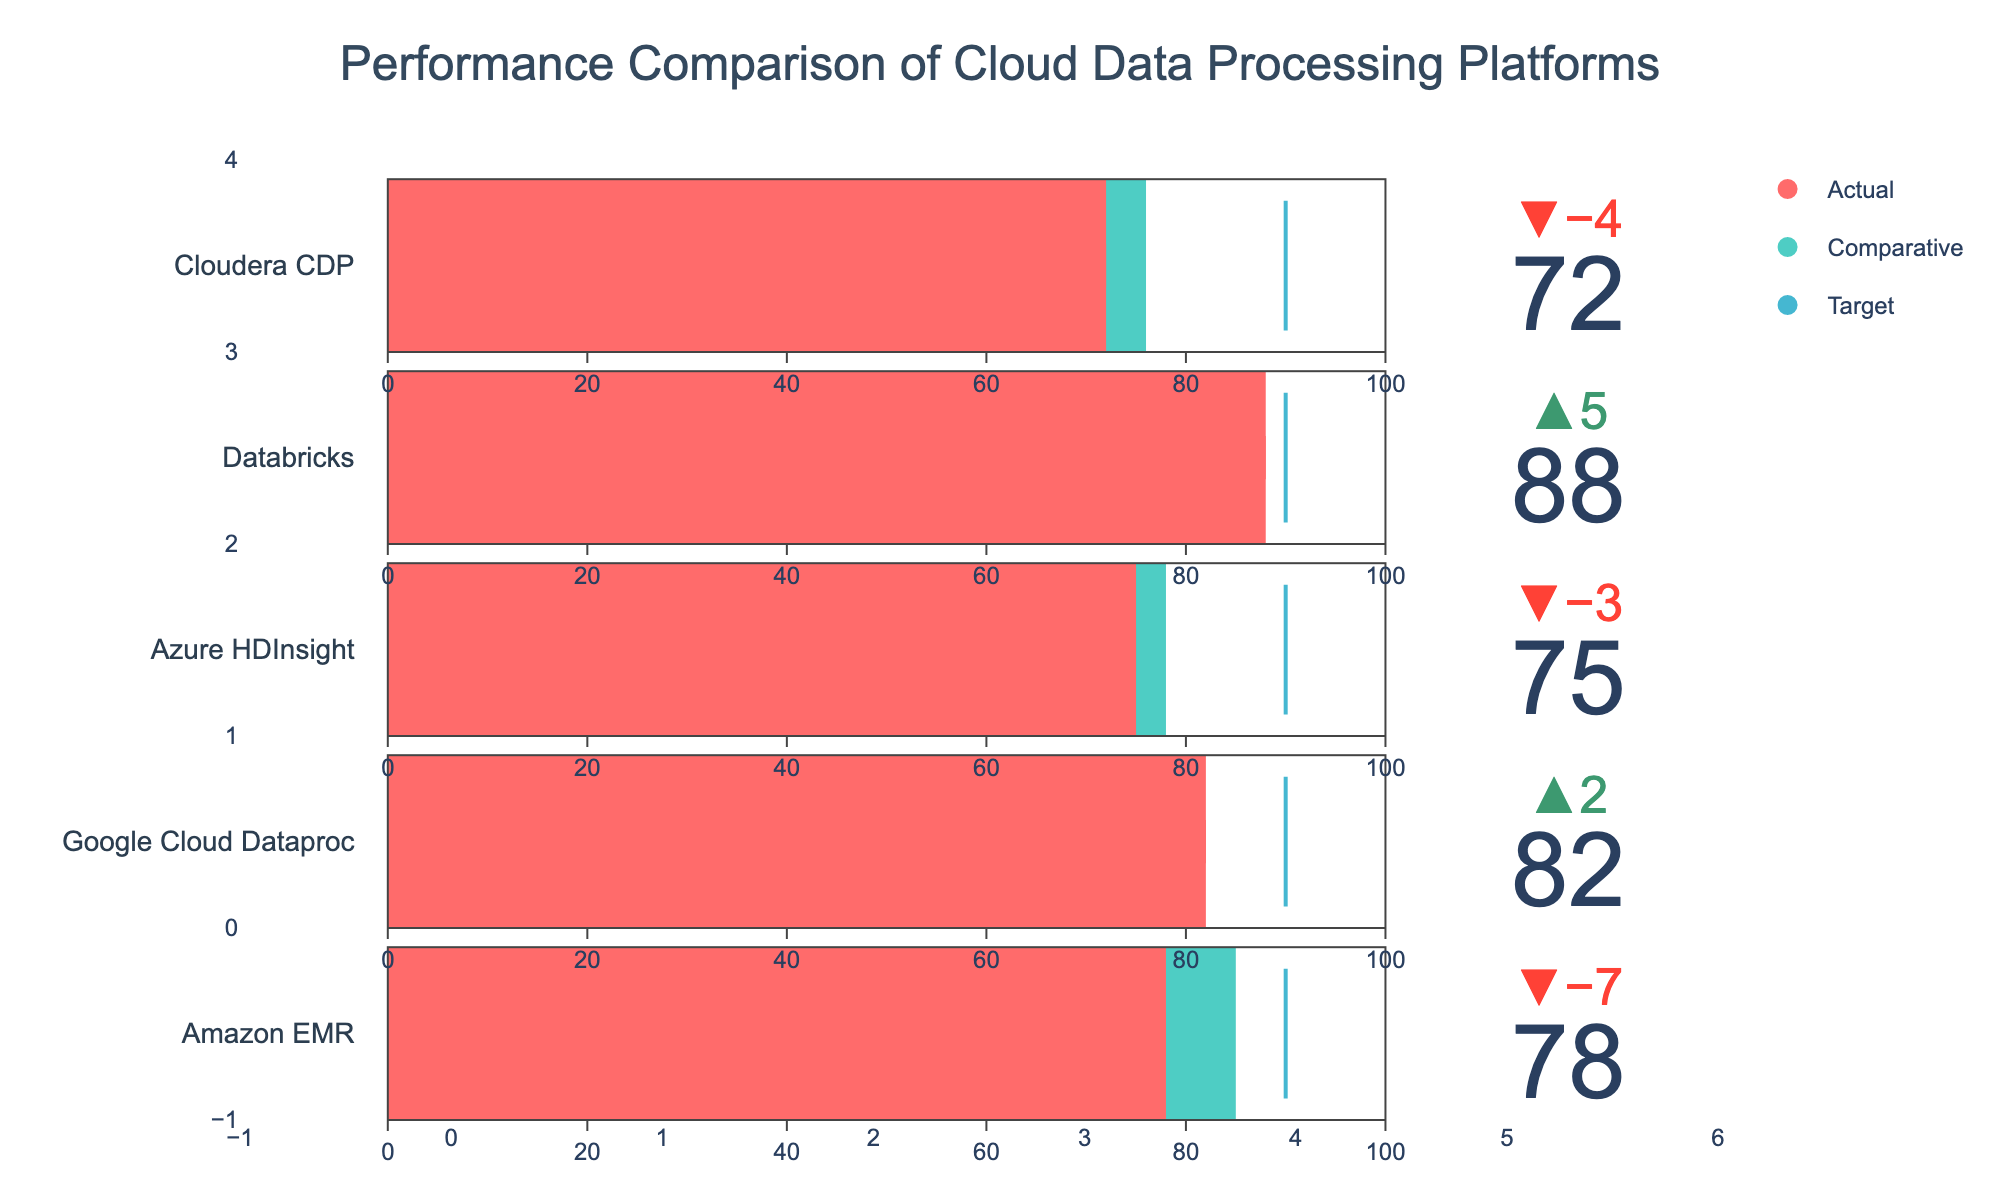What is the title of the plot? The title of the plot is located at the top and clearly states the focus of the visualization. The plot is titled "Performance Comparison of Cloud Data Processing Platforms".
Answer: Performance Comparison of Cloud Data Processing Platforms Which cloud data processing platform has the highest actual performance? To determine the highest actual performance, we need to compare the 'Actual' values of all platforms. Databricks has the highest actual performance of 88.
Answer: Databricks What is the difference between the target and the actual performance of Amazon EMR? The target performance for Amazon EMR is 90, and the actual performance is 78. The difference is calculated as 90 - 78 = 12.
Answer: 12 How many platforms have an actual performance below their comparative performance? We need to count how many platforms have an 'Actual' value less than their 'Comparative' value. Amazon EMR, Azure HDInsight, and Cloudera CDP all have actual performance below their comparative performance.
Answer: 3 Which platform shows the greatest improvement in performance compared to its comparative measure? Improvement is measured by the difference between 'Actual' and 'Comparative'. Databricks shows an improvement of 88 - 83 = 5. Google Cloud Dataproc shows a negative difference, meaning it has lower performance compared to its comparative measure. Therefore, Databricks shows the greatest improvement.
Answer: Databricks Which platform(s) did not meet the target performance of 90? We compare each platform's actual performance against the target of 90. All platforms (Amazon EMR, Google Cloud Dataproc, Azure HDInsight, Databricks, and Cloudera CDP) have actual performances less than 90.
Answer: All platforms What is the average actual performance across all platforms? The actual performances are 78, 82, 75, 88, and 72. Adding them up gives 395. Dividing by the number of platforms (5) gives the average: 395 / 5 = 79.
Answer: 79 Which platform(s) outperformed its comparative measure? To determine outperformance, we check which platforms have 'Actual' values greater than 'Comparative'. Google Cloud Dataproc and Databricks have actual values greater than comparative values.
Answer: Google Cloud Dataproc, Databricks What is the range of comparative performances? The highest comparative performance is 85 (Amazon EMR) and the lowest is 76 (Cloudera CDP). The range is calculated as 85 - 76 = 9.
Answer: 9 Which colors are used to represent the actual, comparative, and target performances? The plot uses specific colors for different performance measures. Actual performance is represented by a certain color, comparative by another, and target by a third color. The colors used are red for actual, teal green for comparative, and blue for target.
Answer: Red, Teal Green, Blue 